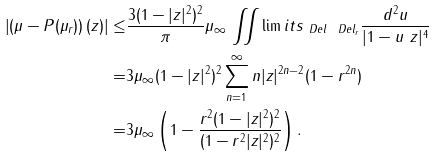<formula> <loc_0><loc_0><loc_500><loc_500>\left | \left ( \mu - P ( \mu _ { r } ) \right ) ( z ) \right | \leq & \frac { 3 ( 1 - | z | ^ { 2 } ) ^ { 2 } } { \pi } \| \mu \| _ { \infty } \, \iint \lim i t s _ { \ D e l \ \ D e l _ { r } } \frac { d ^ { 2 } u } { | 1 - u \ z | ^ { 4 } } \\ = & 3 \| \mu \| _ { \infty } ( 1 - | z | ^ { 2 } ) ^ { 2 } \sum _ { n = 1 } ^ { \infty } n | z | ^ { 2 n - 2 } ( 1 - r ^ { 2 n } ) \\ = & 3 \| \mu \| _ { \infty } \left ( 1 - \frac { r ^ { 2 } ( 1 - | z | ^ { 2 } ) ^ { 2 } } { ( 1 - r ^ { 2 } | z | ^ { 2 } ) ^ { 2 } } \right ) .</formula> 